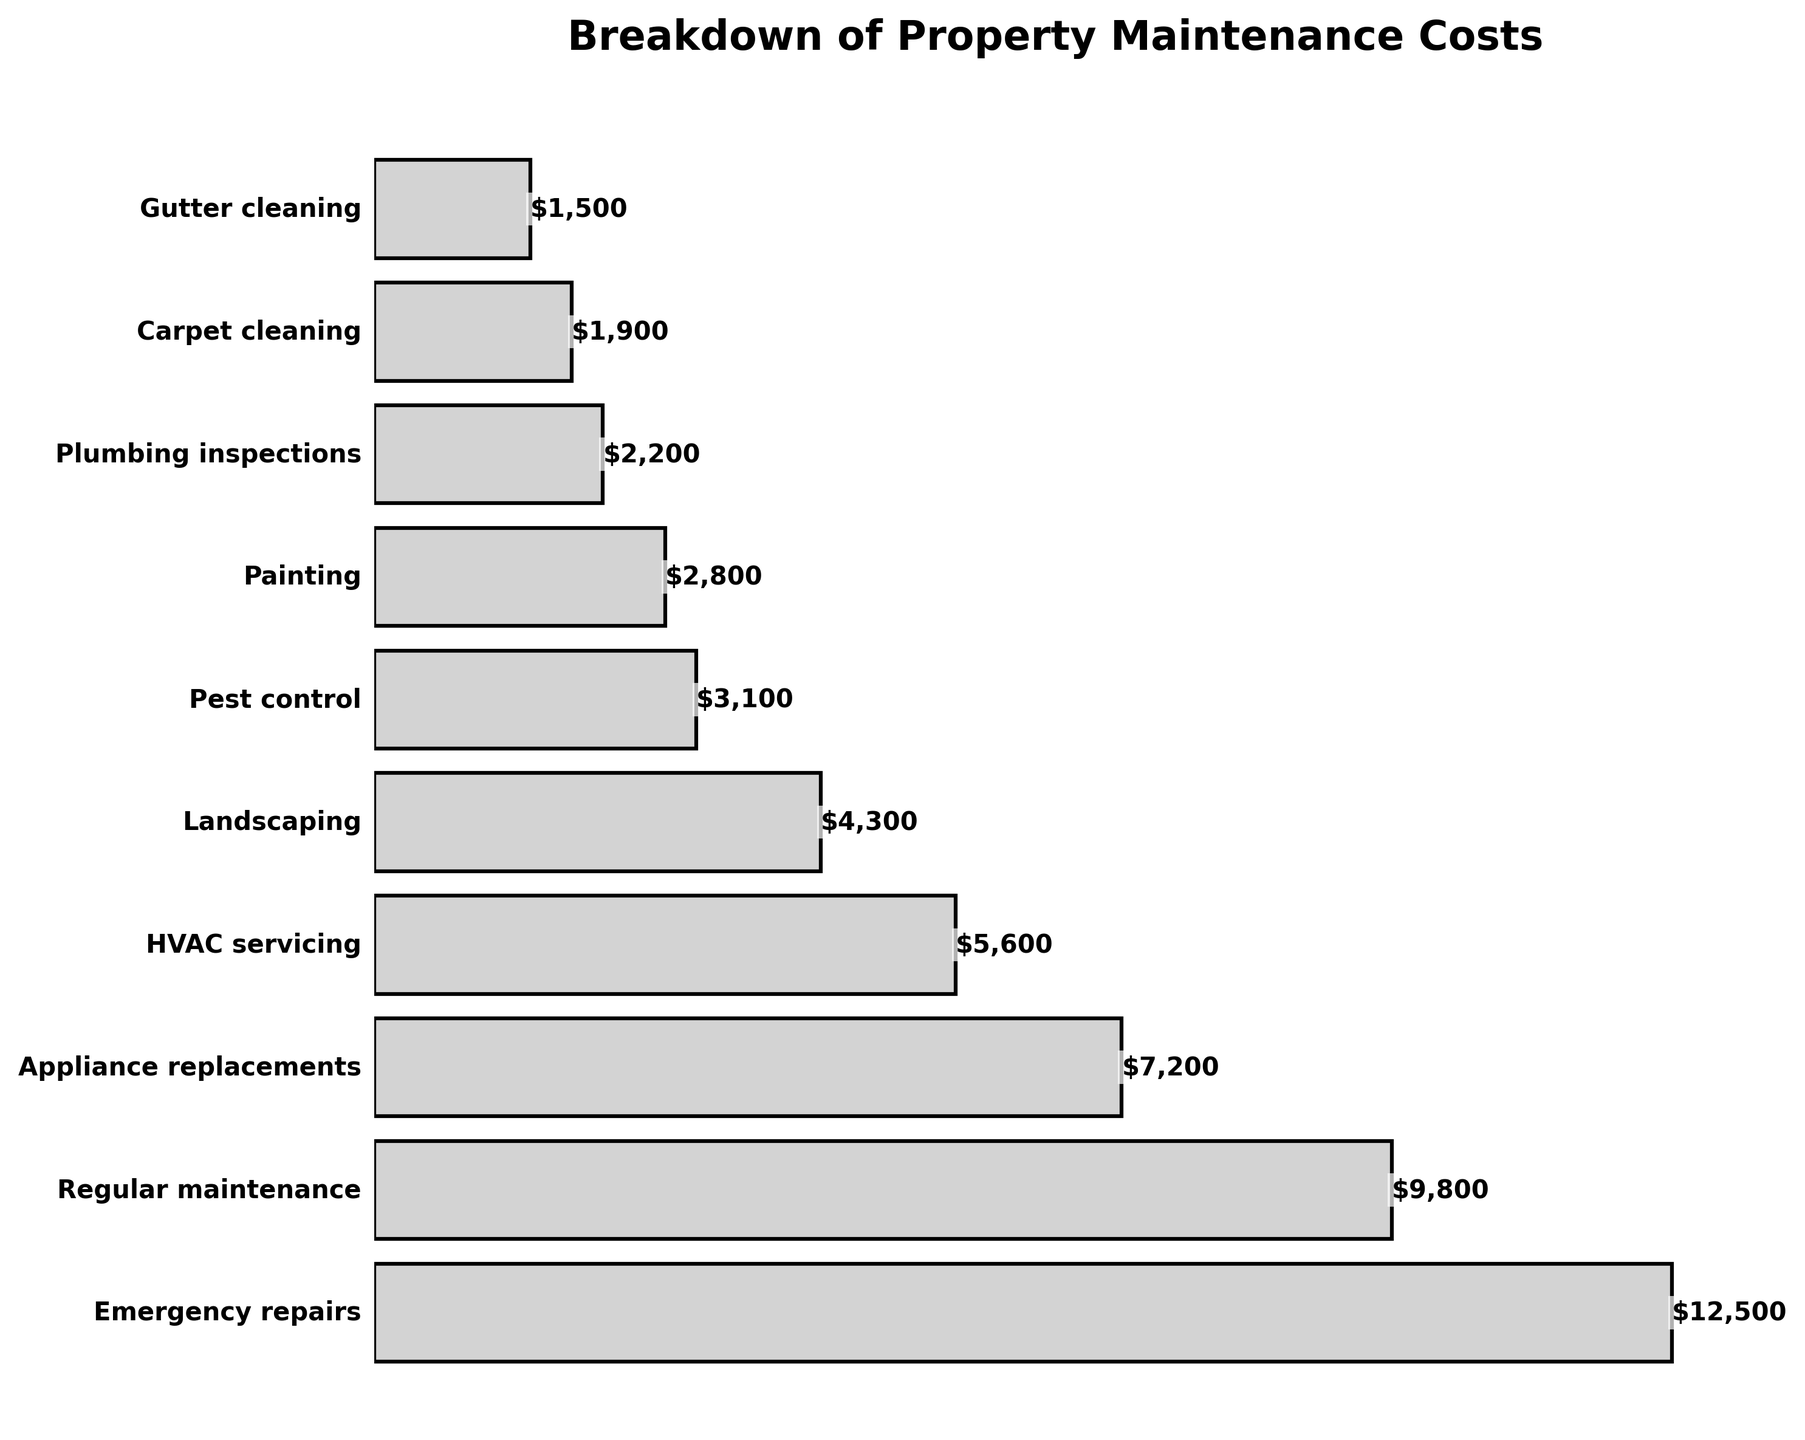What's the total cost of all maintenance categories combined? Add up the costs of all the categories: 12500 (Emergency repairs) + 9800 (Regular maintenance) + 7200 (Appliance replacements) + 5600 (HVAC servicing) + 4300 (Landscaping) + 3100 (Pest control) + 2800 (Painting) + 2200 (Plumbing inspections) + 1900 (Carpet cleaning) + 1500 (Gutter cleaning). The total is 12500 + 9800 + 7200 + 5600 + 4300 + 3100 + 2800 + 2200 + 1900 + 1500 = 49600.
Answer: 49600 Which category has the highest maintenance cost? Locate the longest bar in the funnel chart, which represents the costliest category. The longest bar is for 'Emergency repairs'.
Answer: Emergency repairs What is the difference in cost between Landscaping and Painting? Identify the costs for Landscaping (4300) and Painting (2800). Calculate the difference: 4300 - 2800 = 1500.
Answer: 1500 Are the costs for Pest control and Regular maintenance combined more than Emergency repairs? Identify the costs for Pest control (3100) and Regular maintenance (9800). Add these: 3100 + 9800 = 12900. Compare this with Emergency repairs (12500): 12900 > 12500.
Answer: Yes What is the average cost of the three least expensive categories? Identify the costs for the three least expensive categories: Gutter cleaning (1500), Carpet cleaning (1900), and Plumbing inspections (2200). Calculate the average: (1500 + 1900 + 2200) / 3 = 1866.67.
Answer: 1866.67 Which category has a cost closest to $5000? Identify the costs close to $5000. HVAC servicing costs $5600, which is the closest to $5000.
Answer: HVAC servicing Is the cost of Appliance replacements more than half the cost of Emergency repairs? Identify the costs: Appliance replacements (7200) and Emergency repairs (12500). Calculate half of Emergency repairs: 12500 / 2 = 6250. Compare: 7200 > 6250.
Answer: Yes What proportion of the total cost does Regular maintenance represent? Identify the total cost (49600) and the cost for Regular maintenance (9800). Calculate the proportion: (9800 / 49600) * 100 ≈ 19.76%.
Answer: 19.76% Which has a higher cost, HVAC servicing or Landscaping, and by how much? Identify the costs for HVAC servicing (5600) and Landscaping (4300). Determine the difference: 5600 - 4300 = 1300.
Answer: HVAC servicing by 1300 Can the combined cost of Appliance replacements and HVAC servicing cover the cost of Emergency repairs? Identify the costs: Appliance replacements (7200), HVAC servicing (5600), and Emergency repairs (12500). Combine the costs of Appliance replacements and HVAC servicing: 7200 + 5600 = 12800. Compare this with Emergency repairs: 12800 > 12500.
Answer: Yes 